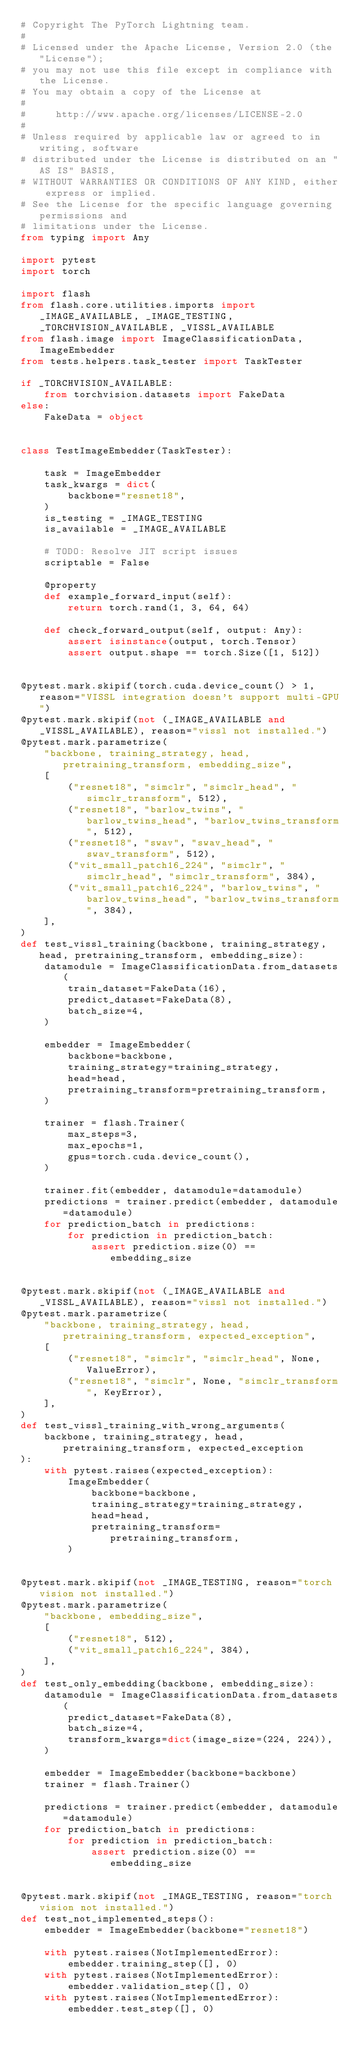Convert code to text. <code><loc_0><loc_0><loc_500><loc_500><_Python_># Copyright The PyTorch Lightning team.
#
# Licensed under the Apache License, Version 2.0 (the "License");
# you may not use this file except in compliance with the License.
# You may obtain a copy of the License at
#
#     http://www.apache.org/licenses/LICENSE-2.0
#
# Unless required by applicable law or agreed to in writing, software
# distributed under the License is distributed on an "AS IS" BASIS,
# WITHOUT WARRANTIES OR CONDITIONS OF ANY KIND, either express or implied.
# See the License for the specific language governing permissions and
# limitations under the License.
from typing import Any

import pytest
import torch

import flash
from flash.core.utilities.imports import _IMAGE_AVAILABLE, _IMAGE_TESTING, _TORCHVISION_AVAILABLE, _VISSL_AVAILABLE
from flash.image import ImageClassificationData, ImageEmbedder
from tests.helpers.task_tester import TaskTester

if _TORCHVISION_AVAILABLE:
    from torchvision.datasets import FakeData
else:
    FakeData = object


class TestImageEmbedder(TaskTester):

    task = ImageEmbedder
    task_kwargs = dict(
        backbone="resnet18",
    )
    is_testing = _IMAGE_TESTING
    is_available = _IMAGE_AVAILABLE

    # TODO: Resolve JIT script issues
    scriptable = False

    @property
    def example_forward_input(self):
        return torch.rand(1, 3, 64, 64)

    def check_forward_output(self, output: Any):
        assert isinstance(output, torch.Tensor)
        assert output.shape == torch.Size([1, 512])


@pytest.mark.skipif(torch.cuda.device_count() > 1, reason="VISSL integration doesn't support multi-GPU")
@pytest.mark.skipif(not (_IMAGE_AVAILABLE and _VISSL_AVAILABLE), reason="vissl not installed.")
@pytest.mark.parametrize(
    "backbone, training_strategy, head, pretraining_transform, embedding_size",
    [
        ("resnet18", "simclr", "simclr_head", "simclr_transform", 512),
        ("resnet18", "barlow_twins", "barlow_twins_head", "barlow_twins_transform", 512),
        ("resnet18", "swav", "swav_head", "swav_transform", 512),
        ("vit_small_patch16_224", "simclr", "simclr_head", "simclr_transform", 384),
        ("vit_small_patch16_224", "barlow_twins", "barlow_twins_head", "barlow_twins_transform", 384),
    ],
)
def test_vissl_training(backbone, training_strategy, head, pretraining_transform, embedding_size):
    datamodule = ImageClassificationData.from_datasets(
        train_dataset=FakeData(16),
        predict_dataset=FakeData(8),
        batch_size=4,
    )

    embedder = ImageEmbedder(
        backbone=backbone,
        training_strategy=training_strategy,
        head=head,
        pretraining_transform=pretraining_transform,
    )

    trainer = flash.Trainer(
        max_steps=3,
        max_epochs=1,
        gpus=torch.cuda.device_count(),
    )

    trainer.fit(embedder, datamodule=datamodule)
    predictions = trainer.predict(embedder, datamodule=datamodule)
    for prediction_batch in predictions:
        for prediction in prediction_batch:
            assert prediction.size(0) == embedding_size


@pytest.mark.skipif(not (_IMAGE_AVAILABLE and _VISSL_AVAILABLE), reason="vissl not installed.")
@pytest.mark.parametrize(
    "backbone, training_strategy, head, pretraining_transform, expected_exception",
    [
        ("resnet18", "simclr", "simclr_head", None, ValueError),
        ("resnet18", "simclr", None, "simclr_transform", KeyError),
    ],
)
def test_vissl_training_with_wrong_arguments(
    backbone, training_strategy, head, pretraining_transform, expected_exception
):
    with pytest.raises(expected_exception):
        ImageEmbedder(
            backbone=backbone,
            training_strategy=training_strategy,
            head=head,
            pretraining_transform=pretraining_transform,
        )


@pytest.mark.skipif(not _IMAGE_TESTING, reason="torch vision not installed.")
@pytest.mark.parametrize(
    "backbone, embedding_size",
    [
        ("resnet18", 512),
        ("vit_small_patch16_224", 384),
    ],
)
def test_only_embedding(backbone, embedding_size):
    datamodule = ImageClassificationData.from_datasets(
        predict_dataset=FakeData(8),
        batch_size=4,
        transform_kwargs=dict(image_size=(224, 224)),
    )

    embedder = ImageEmbedder(backbone=backbone)
    trainer = flash.Trainer()

    predictions = trainer.predict(embedder, datamodule=datamodule)
    for prediction_batch in predictions:
        for prediction in prediction_batch:
            assert prediction.size(0) == embedding_size


@pytest.mark.skipif(not _IMAGE_TESTING, reason="torch vision not installed.")
def test_not_implemented_steps():
    embedder = ImageEmbedder(backbone="resnet18")

    with pytest.raises(NotImplementedError):
        embedder.training_step([], 0)
    with pytest.raises(NotImplementedError):
        embedder.validation_step([], 0)
    with pytest.raises(NotImplementedError):
        embedder.test_step([], 0)
</code> 